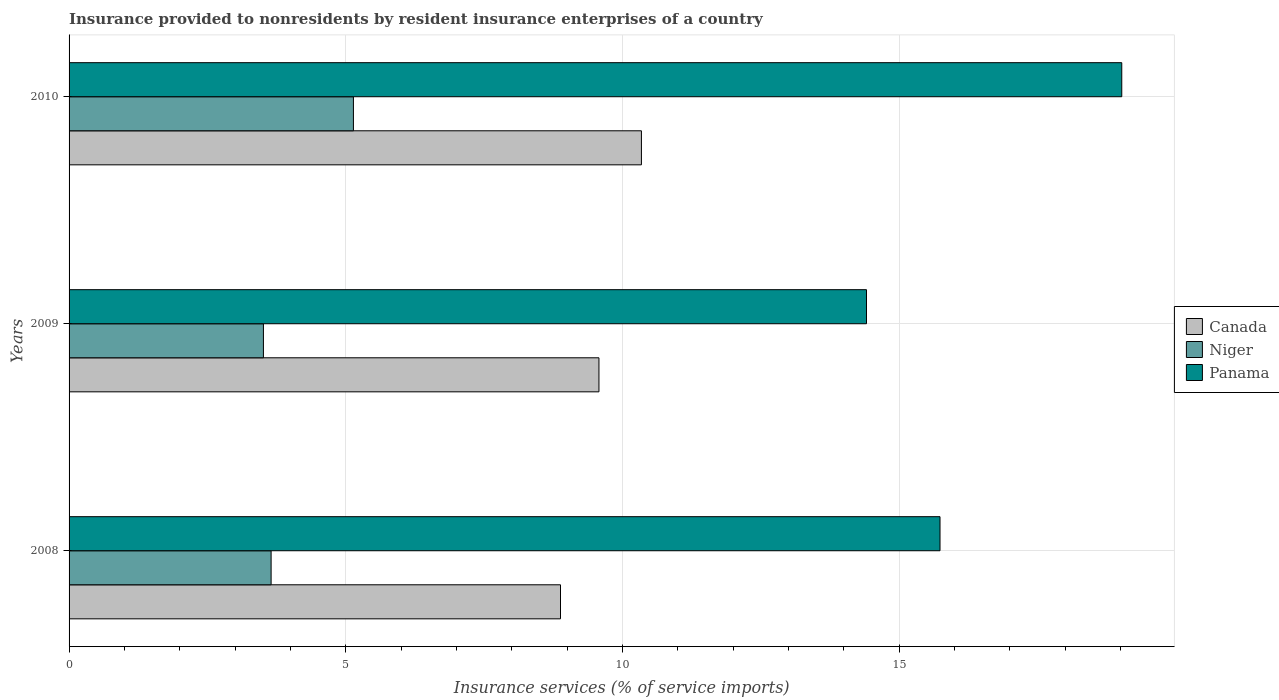How many different coloured bars are there?
Provide a short and direct response. 3. How many groups of bars are there?
Offer a terse response. 3. Are the number of bars per tick equal to the number of legend labels?
Give a very brief answer. Yes. Are the number of bars on each tick of the Y-axis equal?
Provide a succinct answer. Yes. How many bars are there on the 2nd tick from the bottom?
Give a very brief answer. 3. What is the insurance provided to nonresidents in Panama in 2010?
Your answer should be very brief. 19.02. Across all years, what is the maximum insurance provided to nonresidents in Niger?
Offer a very short reply. 5.14. Across all years, what is the minimum insurance provided to nonresidents in Canada?
Provide a short and direct response. 8.88. What is the total insurance provided to nonresidents in Canada in the graph?
Your response must be concise. 28.8. What is the difference between the insurance provided to nonresidents in Niger in 2008 and that in 2010?
Keep it short and to the point. -1.49. What is the difference between the insurance provided to nonresidents in Canada in 2010 and the insurance provided to nonresidents in Panama in 2009?
Your response must be concise. -4.07. What is the average insurance provided to nonresidents in Niger per year?
Your answer should be compact. 4.1. In the year 2009, what is the difference between the insurance provided to nonresidents in Panama and insurance provided to nonresidents in Canada?
Offer a very short reply. 4.83. In how many years, is the insurance provided to nonresidents in Panama greater than 9 %?
Your answer should be compact. 3. What is the ratio of the insurance provided to nonresidents in Niger in 2009 to that in 2010?
Your response must be concise. 0.68. What is the difference between the highest and the second highest insurance provided to nonresidents in Niger?
Your answer should be very brief. 1.49. What is the difference between the highest and the lowest insurance provided to nonresidents in Canada?
Keep it short and to the point. 1.46. In how many years, is the insurance provided to nonresidents in Niger greater than the average insurance provided to nonresidents in Niger taken over all years?
Give a very brief answer. 1. Is the sum of the insurance provided to nonresidents in Canada in 2009 and 2010 greater than the maximum insurance provided to nonresidents in Panama across all years?
Give a very brief answer. Yes. What does the 2nd bar from the top in 2008 represents?
Provide a short and direct response. Niger. What does the 3rd bar from the bottom in 2008 represents?
Your response must be concise. Panama. Are all the bars in the graph horizontal?
Ensure brevity in your answer.  Yes. Are the values on the major ticks of X-axis written in scientific E-notation?
Offer a very short reply. No. Does the graph contain any zero values?
Your answer should be compact. No. How many legend labels are there?
Make the answer very short. 3. What is the title of the graph?
Give a very brief answer. Insurance provided to nonresidents by resident insurance enterprises of a country. What is the label or title of the X-axis?
Provide a succinct answer. Insurance services (% of service imports). What is the Insurance services (% of service imports) of Canada in 2008?
Your answer should be compact. 8.88. What is the Insurance services (% of service imports) of Niger in 2008?
Give a very brief answer. 3.65. What is the Insurance services (% of service imports) in Panama in 2008?
Give a very brief answer. 15.74. What is the Insurance services (% of service imports) in Canada in 2009?
Offer a very short reply. 9.58. What is the Insurance services (% of service imports) of Niger in 2009?
Provide a short and direct response. 3.51. What is the Insurance services (% of service imports) of Panama in 2009?
Your response must be concise. 14.41. What is the Insurance services (% of service imports) of Canada in 2010?
Ensure brevity in your answer.  10.34. What is the Insurance services (% of service imports) of Niger in 2010?
Your response must be concise. 5.14. What is the Insurance services (% of service imports) of Panama in 2010?
Your answer should be very brief. 19.02. Across all years, what is the maximum Insurance services (% of service imports) in Canada?
Provide a short and direct response. 10.34. Across all years, what is the maximum Insurance services (% of service imports) of Niger?
Your answer should be compact. 5.14. Across all years, what is the maximum Insurance services (% of service imports) in Panama?
Ensure brevity in your answer.  19.02. Across all years, what is the minimum Insurance services (% of service imports) of Canada?
Your answer should be compact. 8.88. Across all years, what is the minimum Insurance services (% of service imports) in Niger?
Your answer should be compact. 3.51. Across all years, what is the minimum Insurance services (% of service imports) of Panama?
Offer a very short reply. 14.41. What is the total Insurance services (% of service imports) in Canada in the graph?
Your answer should be compact. 28.8. What is the total Insurance services (% of service imports) in Niger in the graph?
Provide a short and direct response. 12.3. What is the total Insurance services (% of service imports) in Panama in the graph?
Give a very brief answer. 49.17. What is the difference between the Insurance services (% of service imports) in Canada in 2008 and that in 2009?
Give a very brief answer. -0.7. What is the difference between the Insurance services (% of service imports) in Niger in 2008 and that in 2009?
Ensure brevity in your answer.  0.14. What is the difference between the Insurance services (% of service imports) of Panama in 2008 and that in 2009?
Make the answer very short. 1.33. What is the difference between the Insurance services (% of service imports) in Canada in 2008 and that in 2010?
Your answer should be very brief. -1.46. What is the difference between the Insurance services (% of service imports) of Niger in 2008 and that in 2010?
Ensure brevity in your answer.  -1.49. What is the difference between the Insurance services (% of service imports) in Panama in 2008 and that in 2010?
Make the answer very short. -3.28. What is the difference between the Insurance services (% of service imports) of Canada in 2009 and that in 2010?
Provide a succinct answer. -0.77. What is the difference between the Insurance services (% of service imports) of Niger in 2009 and that in 2010?
Your answer should be very brief. -1.63. What is the difference between the Insurance services (% of service imports) in Panama in 2009 and that in 2010?
Make the answer very short. -4.61. What is the difference between the Insurance services (% of service imports) of Canada in 2008 and the Insurance services (% of service imports) of Niger in 2009?
Make the answer very short. 5.37. What is the difference between the Insurance services (% of service imports) of Canada in 2008 and the Insurance services (% of service imports) of Panama in 2009?
Ensure brevity in your answer.  -5.53. What is the difference between the Insurance services (% of service imports) of Niger in 2008 and the Insurance services (% of service imports) of Panama in 2009?
Your answer should be compact. -10.76. What is the difference between the Insurance services (% of service imports) in Canada in 2008 and the Insurance services (% of service imports) in Niger in 2010?
Provide a short and direct response. 3.74. What is the difference between the Insurance services (% of service imports) of Canada in 2008 and the Insurance services (% of service imports) of Panama in 2010?
Keep it short and to the point. -10.14. What is the difference between the Insurance services (% of service imports) of Niger in 2008 and the Insurance services (% of service imports) of Panama in 2010?
Offer a very short reply. -15.37. What is the difference between the Insurance services (% of service imports) of Canada in 2009 and the Insurance services (% of service imports) of Niger in 2010?
Provide a short and direct response. 4.44. What is the difference between the Insurance services (% of service imports) of Canada in 2009 and the Insurance services (% of service imports) of Panama in 2010?
Offer a very short reply. -9.45. What is the difference between the Insurance services (% of service imports) of Niger in 2009 and the Insurance services (% of service imports) of Panama in 2010?
Your response must be concise. -15.51. What is the average Insurance services (% of service imports) of Canada per year?
Offer a very short reply. 9.6. What is the average Insurance services (% of service imports) of Niger per year?
Your response must be concise. 4.1. What is the average Insurance services (% of service imports) in Panama per year?
Keep it short and to the point. 16.39. In the year 2008, what is the difference between the Insurance services (% of service imports) of Canada and Insurance services (% of service imports) of Niger?
Ensure brevity in your answer.  5.23. In the year 2008, what is the difference between the Insurance services (% of service imports) in Canada and Insurance services (% of service imports) in Panama?
Make the answer very short. -6.86. In the year 2008, what is the difference between the Insurance services (% of service imports) in Niger and Insurance services (% of service imports) in Panama?
Give a very brief answer. -12.09. In the year 2009, what is the difference between the Insurance services (% of service imports) in Canada and Insurance services (% of service imports) in Niger?
Your answer should be very brief. 6.06. In the year 2009, what is the difference between the Insurance services (% of service imports) in Canada and Insurance services (% of service imports) in Panama?
Keep it short and to the point. -4.83. In the year 2009, what is the difference between the Insurance services (% of service imports) in Niger and Insurance services (% of service imports) in Panama?
Offer a terse response. -10.9. In the year 2010, what is the difference between the Insurance services (% of service imports) in Canada and Insurance services (% of service imports) in Niger?
Your response must be concise. 5.2. In the year 2010, what is the difference between the Insurance services (% of service imports) in Canada and Insurance services (% of service imports) in Panama?
Ensure brevity in your answer.  -8.68. In the year 2010, what is the difference between the Insurance services (% of service imports) of Niger and Insurance services (% of service imports) of Panama?
Your answer should be very brief. -13.88. What is the ratio of the Insurance services (% of service imports) in Canada in 2008 to that in 2009?
Make the answer very short. 0.93. What is the ratio of the Insurance services (% of service imports) in Niger in 2008 to that in 2009?
Make the answer very short. 1.04. What is the ratio of the Insurance services (% of service imports) of Panama in 2008 to that in 2009?
Give a very brief answer. 1.09. What is the ratio of the Insurance services (% of service imports) of Canada in 2008 to that in 2010?
Make the answer very short. 0.86. What is the ratio of the Insurance services (% of service imports) in Niger in 2008 to that in 2010?
Give a very brief answer. 0.71. What is the ratio of the Insurance services (% of service imports) of Panama in 2008 to that in 2010?
Provide a succinct answer. 0.83. What is the ratio of the Insurance services (% of service imports) of Canada in 2009 to that in 2010?
Ensure brevity in your answer.  0.93. What is the ratio of the Insurance services (% of service imports) in Niger in 2009 to that in 2010?
Your answer should be very brief. 0.68. What is the ratio of the Insurance services (% of service imports) of Panama in 2009 to that in 2010?
Your response must be concise. 0.76. What is the difference between the highest and the second highest Insurance services (% of service imports) in Canada?
Your answer should be very brief. 0.77. What is the difference between the highest and the second highest Insurance services (% of service imports) in Niger?
Give a very brief answer. 1.49. What is the difference between the highest and the second highest Insurance services (% of service imports) in Panama?
Offer a terse response. 3.28. What is the difference between the highest and the lowest Insurance services (% of service imports) in Canada?
Provide a short and direct response. 1.46. What is the difference between the highest and the lowest Insurance services (% of service imports) of Niger?
Your answer should be compact. 1.63. What is the difference between the highest and the lowest Insurance services (% of service imports) of Panama?
Make the answer very short. 4.61. 